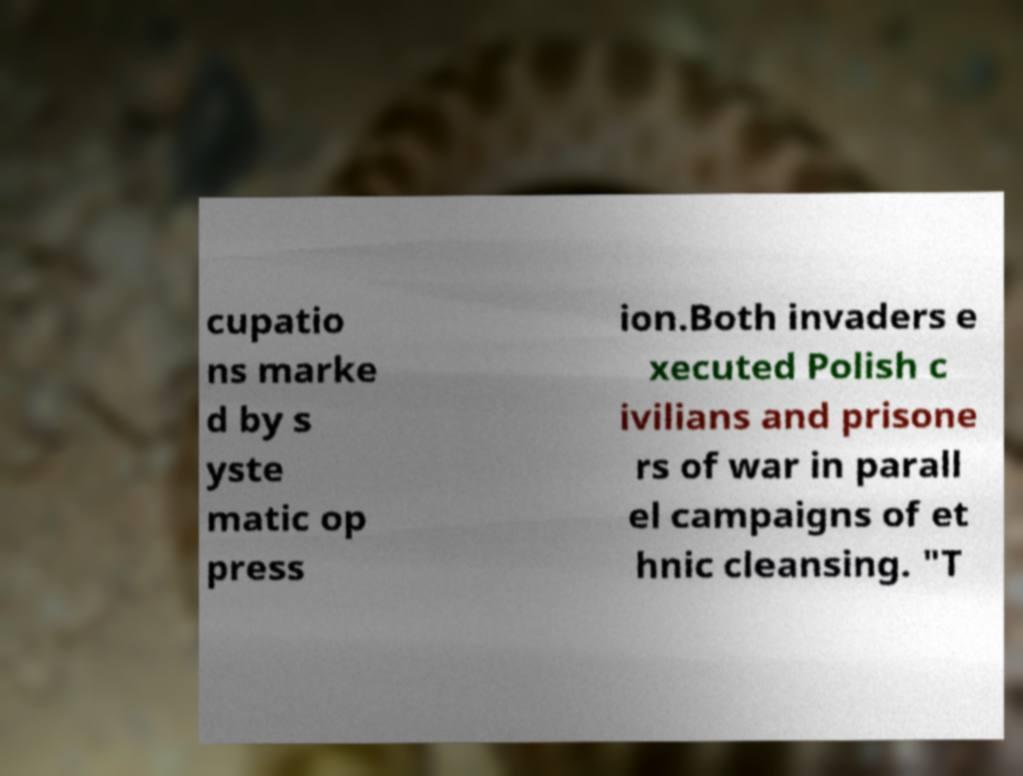Could you extract and type out the text from this image? cupatio ns marke d by s yste matic op press ion.Both invaders e xecuted Polish c ivilians and prisone rs of war in parall el campaigns of et hnic cleansing. "T 